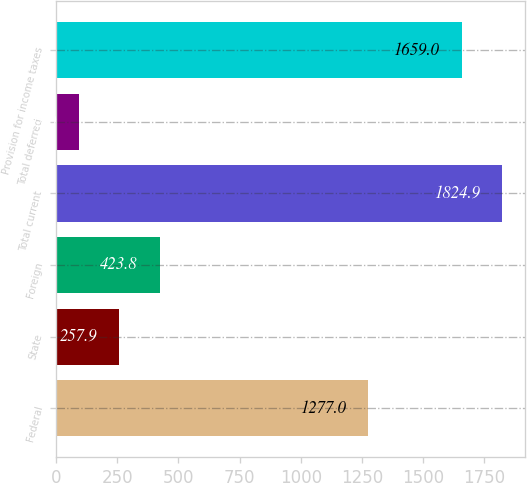<chart> <loc_0><loc_0><loc_500><loc_500><bar_chart><fcel>Federal<fcel>State<fcel>Foreign<fcel>Total current<fcel>Total deferred<fcel>Provision for income taxes<nl><fcel>1277<fcel>257.9<fcel>423.8<fcel>1824.9<fcel>92<fcel>1659<nl></chart> 